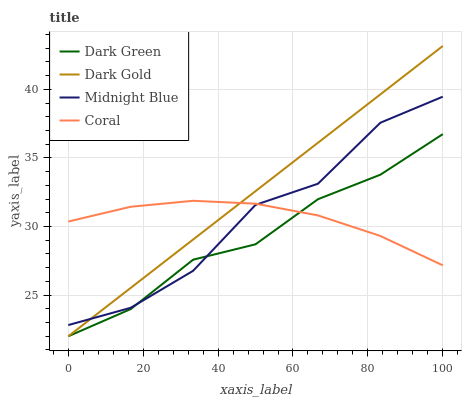Does Dark Green have the minimum area under the curve?
Answer yes or no. Yes. Does Dark Gold have the maximum area under the curve?
Answer yes or no. Yes. Does Midnight Blue have the minimum area under the curve?
Answer yes or no. No. Does Midnight Blue have the maximum area under the curve?
Answer yes or no. No. Is Dark Gold the smoothest?
Answer yes or no. Yes. Is Midnight Blue the roughest?
Answer yes or no. Yes. Is Midnight Blue the smoothest?
Answer yes or no. No. Is Dark Gold the roughest?
Answer yes or no. No. Does Dark Gold have the lowest value?
Answer yes or no. Yes. Does Midnight Blue have the lowest value?
Answer yes or no. No. Does Dark Gold have the highest value?
Answer yes or no. Yes. Does Midnight Blue have the highest value?
Answer yes or no. No. Does Midnight Blue intersect Coral?
Answer yes or no. Yes. Is Midnight Blue less than Coral?
Answer yes or no. No. Is Midnight Blue greater than Coral?
Answer yes or no. No. 